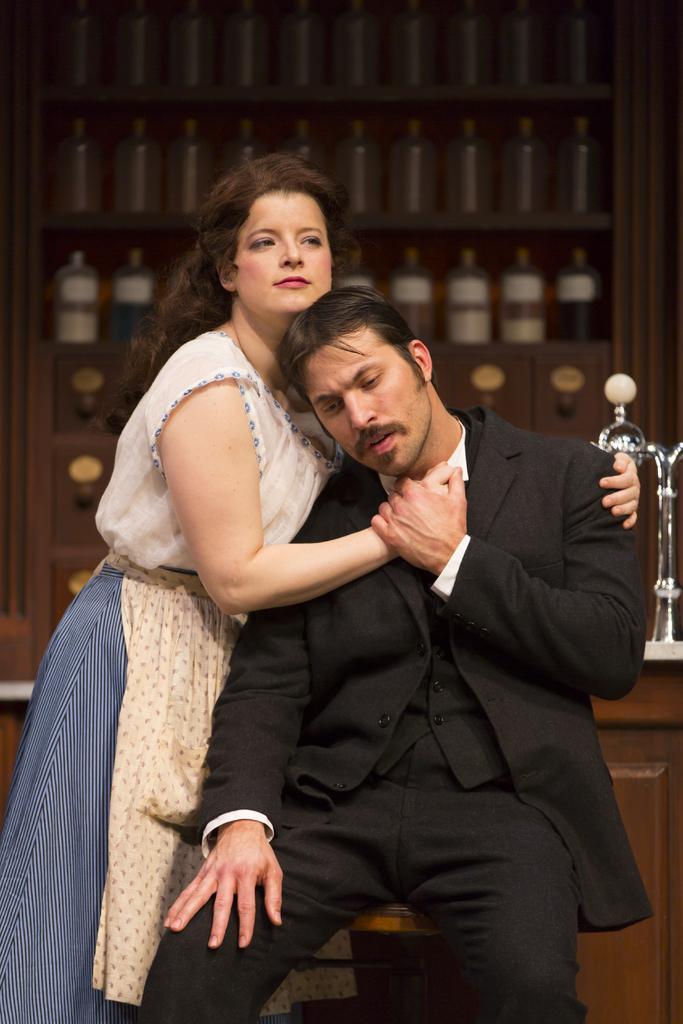Describe this image in one or two sentences. As we can see in the image in the front there are two people. The man is wearing black color jacket and the woman is wearing white color dress. In the background there are bottles. 